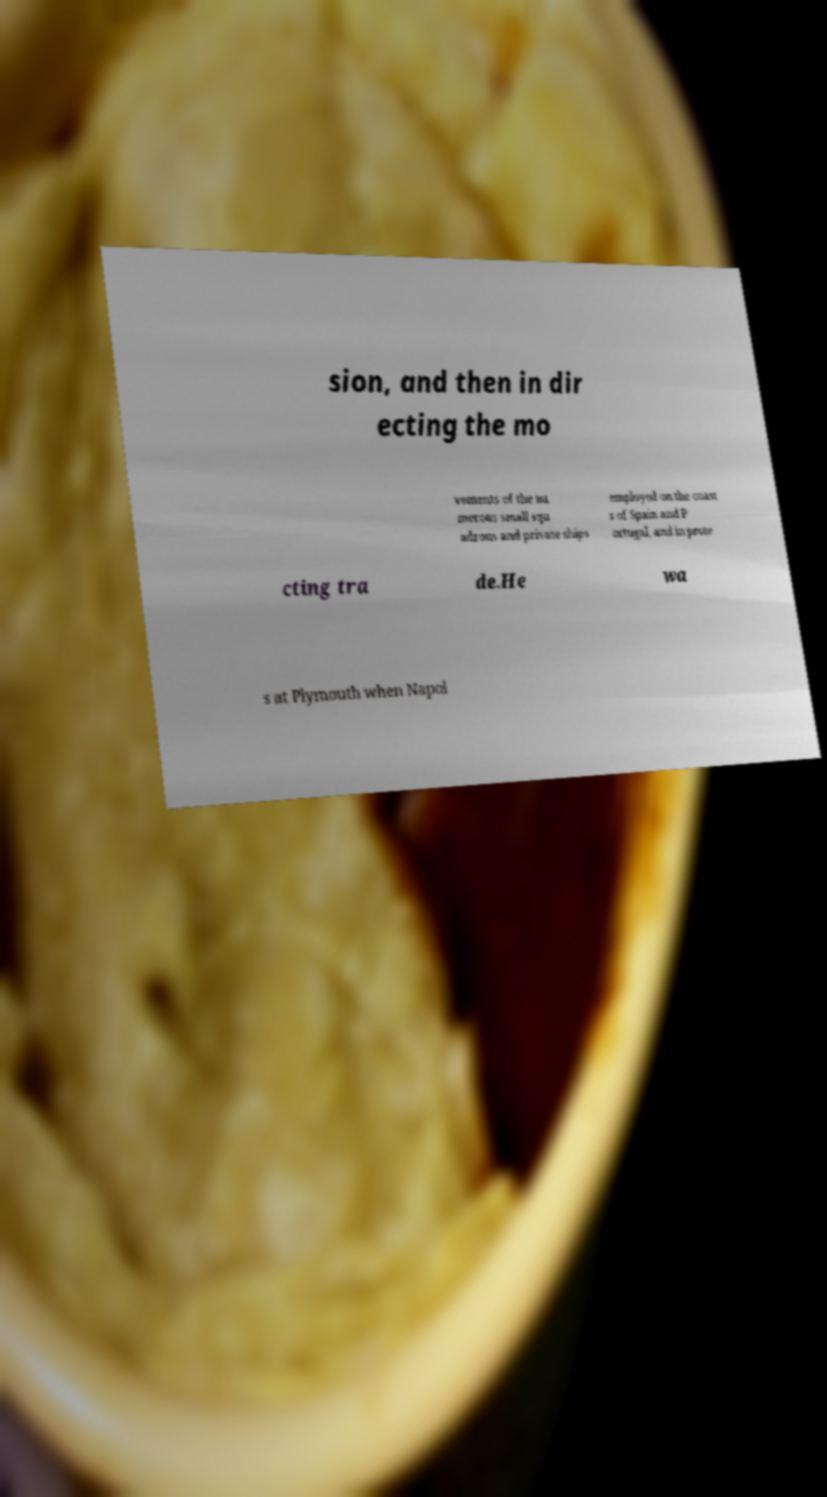For documentation purposes, I need the text within this image transcribed. Could you provide that? sion, and then in dir ecting the mo vements of the nu merous small squ adrons and private ships employed on the coast s of Spain and P ortugal, and in prote cting tra de.He wa s at Plymouth when Napol 